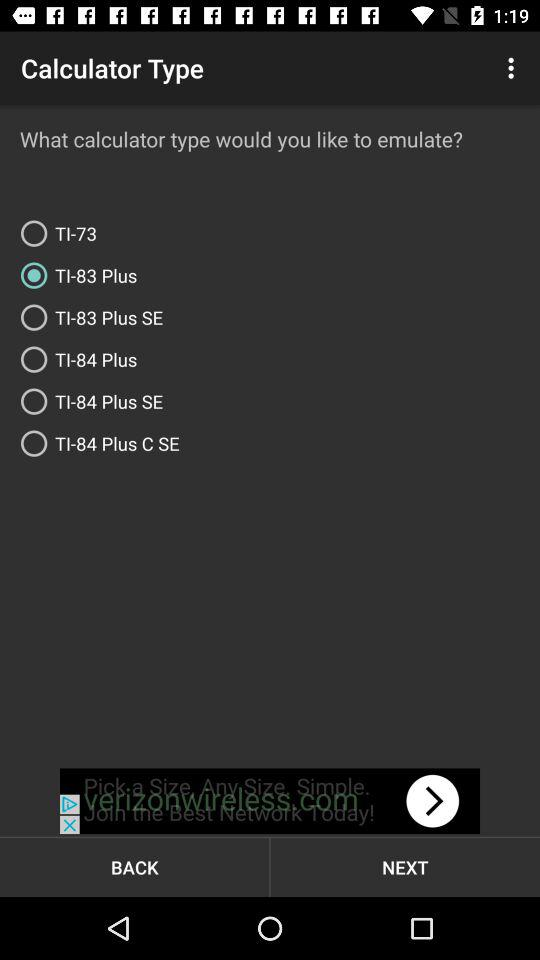Which option is selected? The selected option is "I already have a ROM file". 